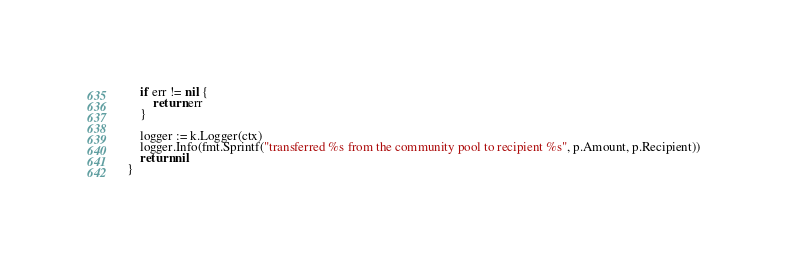<code> <loc_0><loc_0><loc_500><loc_500><_Go_>	if err != nil {
		return err
	}

	logger := k.Logger(ctx)
	logger.Info(fmt.Sprintf("transferred %s from the community pool to recipient %s", p.Amount, p.Recipient))
	return nil
}
</code> 